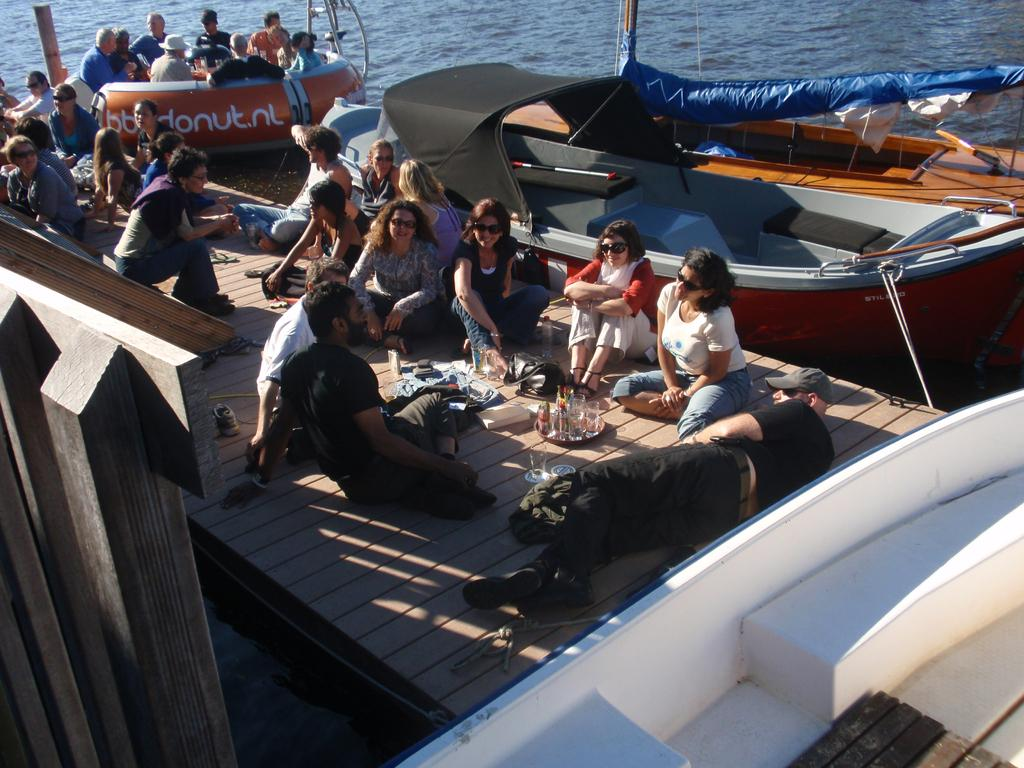How many people are in the image? There is a group of people in the image, but the exact number is not specified. What can be seen on the water in the image? There are boats on the water in the image. What objects are visible in the image that can be used for drinking? There are glasses in the image. What type of container is present in the image? There is a bag in the image. Can you describe any other objects or features in the image? There are other unspecified things in the image, but their details are not provided. How many bikes are parked next to the bag in the image? There is no mention of bikes in the image, so we cannot determine how many there are. What type of comb is being used by the people in the image? There is no comb present in the image, so we cannot describe its type. 